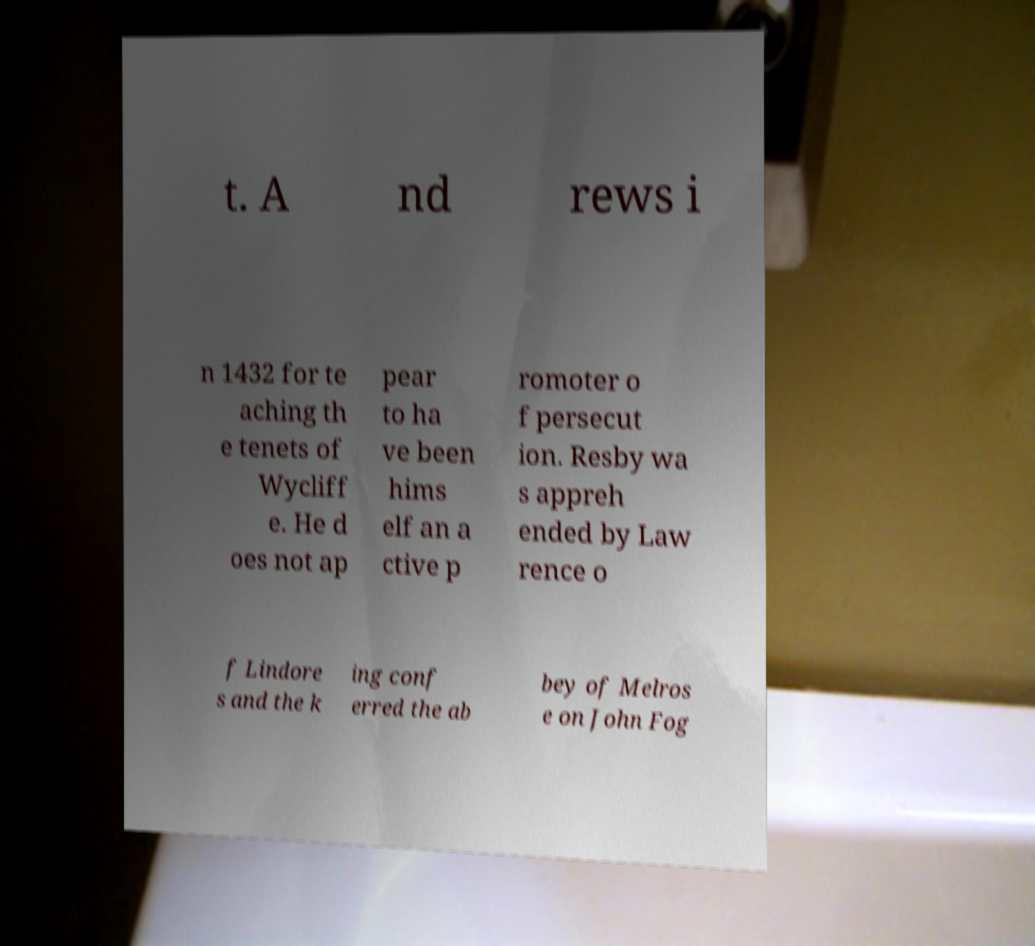For documentation purposes, I need the text within this image transcribed. Could you provide that? t. A nd rews i n 1432 for te aching th e tenets of Wycliff e. He d oes not ap pear to ha ve been hims elf an a ctive p romoter o f persecut ion. Resby wa s appreh ended by Law rence o f Lindore s and the k ing conf erred the ab bey of Melros e on John Fog 